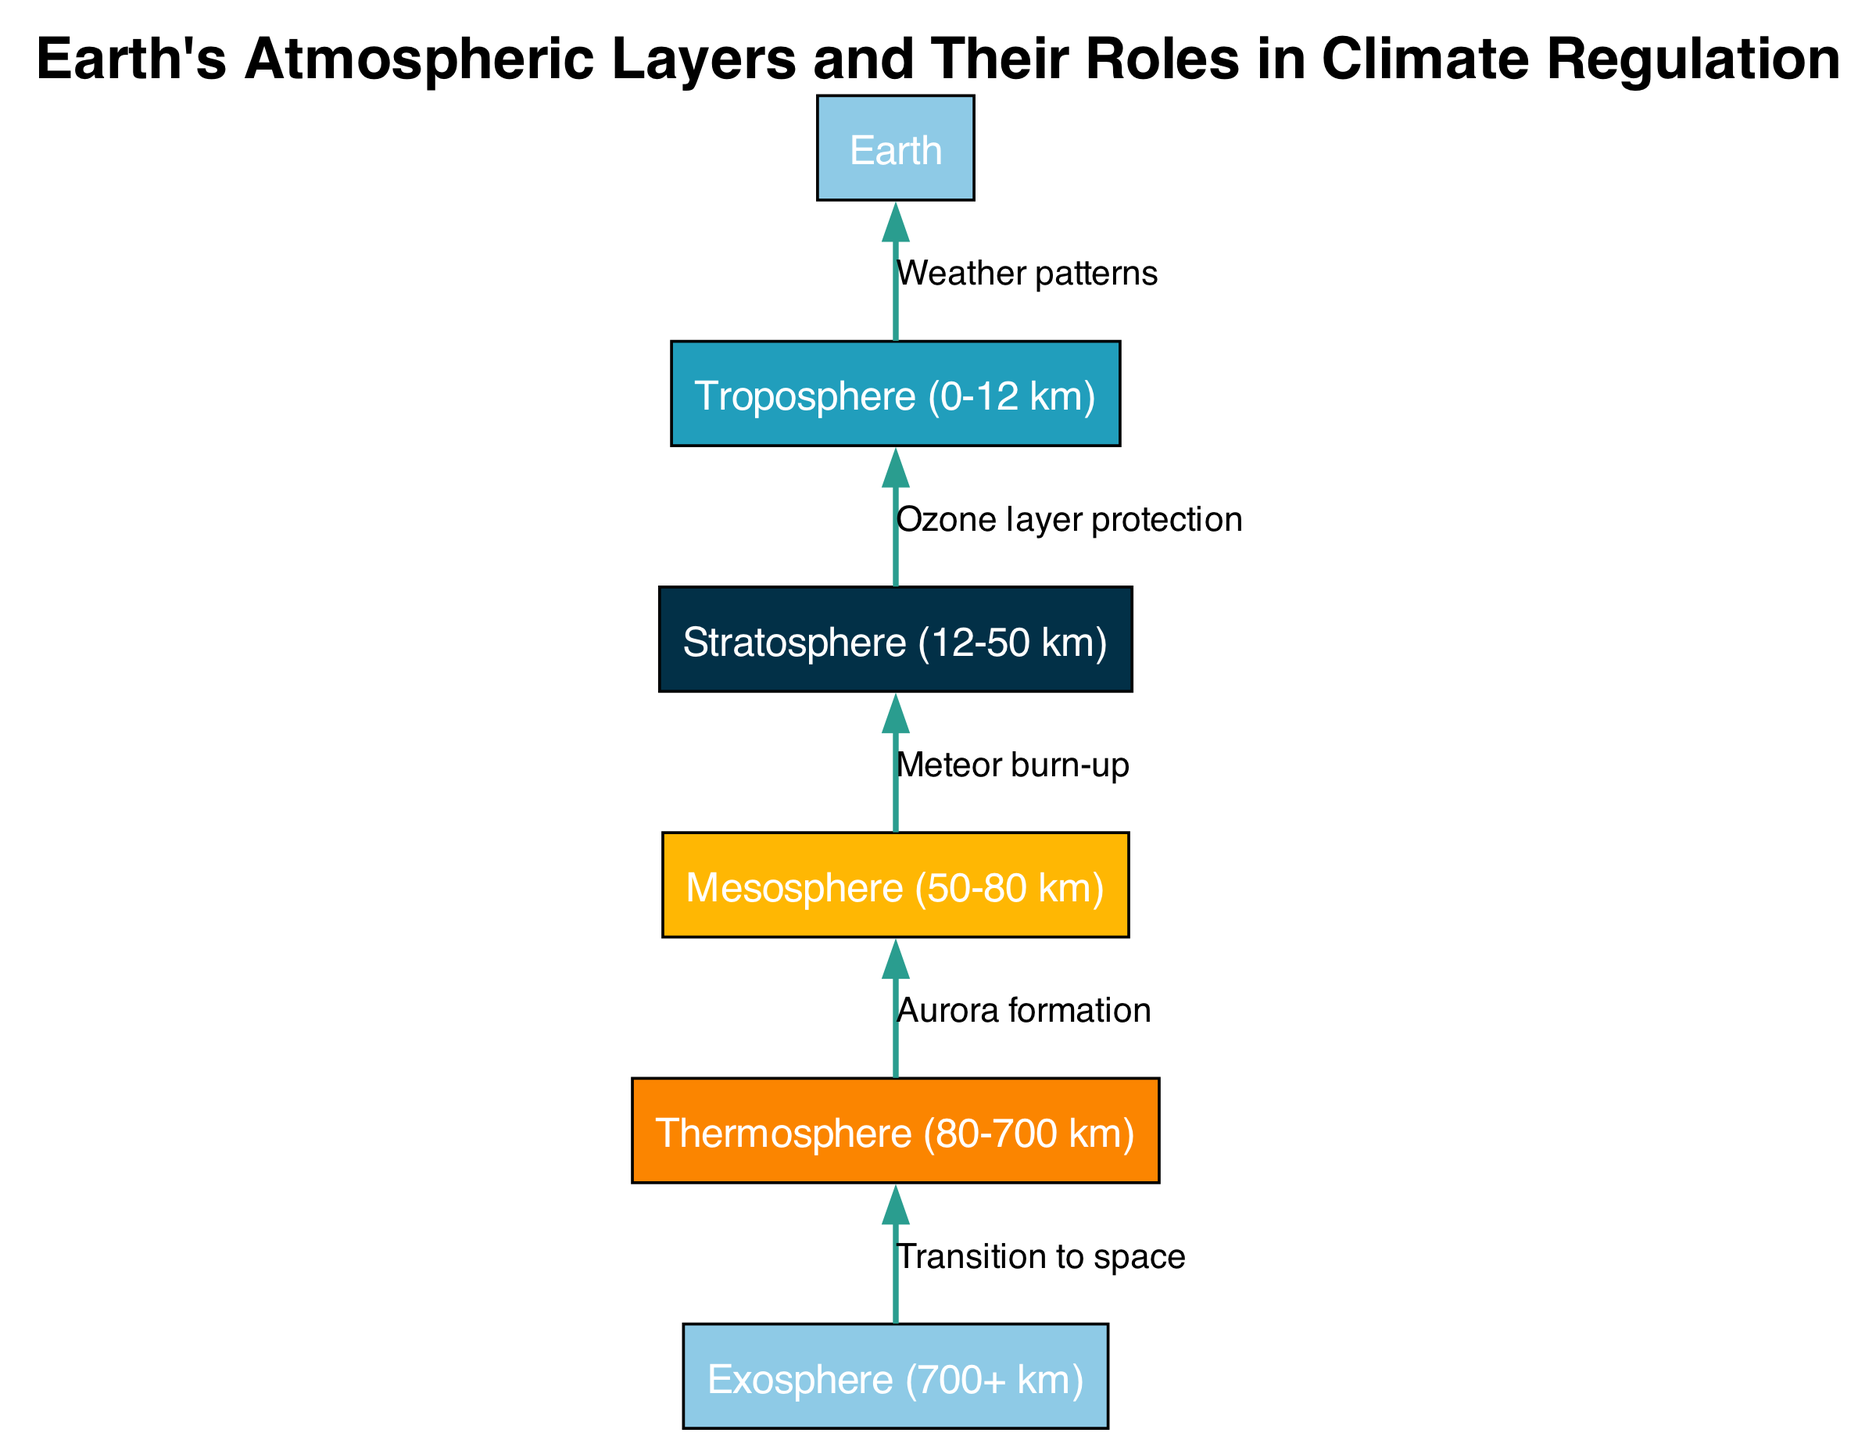What is the highest atmospheric layer shown in the diagram? The highest layer illustrated in the diagram is identified as the Exosphere, which extends beyond 700 kilometers above Earth.
Answer: Exosphere (700+ km) How many layers of the atmosphere are represented? The diagram includes five distinct atmospheric layers: Troposphere, Stratosphere, Mesosphere, Thermosphere, and Exosphere, totaling five layers.
Answer: 5 What is the role of the Stratosphere? The Stratosphere is primarily associated with Ozone layer protection, which plays a crucial role in filtering harmful UV radiation from the sun and thereby protects life on Earth.
Answer: Ozone layer protection Which layer is responsible for weather patterns? The Troposphere is directly linked with weather patterns, as it is where most weather events, such as clouds and storms, occur.
Answer: Troposphere (0-12 km) Which layer does the Thermosphere directly influence? The Thermosphere influences the Mesosphere as it transitions to the higher atmospheric region, playing a role in phenomena such as aurora formation.
Answer: Mesosphere What connects the Mesosphere and the Stratosphere? The connection between the Mesosphere and the Stratosphere is characterized by meteor burn-up occurring in the Mesosphere, which is visually represented by an edge labeled 'Meteor burn-up'.
Answer: Meteor burn-up From which layer does the transition to space begin? The transition to space begins from the Exosphere, as indicated by its positioning and the corresponding label in the diagram that signifies movement beyond Earth's atmosphere.
Answer: Exosphere (700+ km) What visual element indicates relationship direction? The edges between nodes are used as visual elements to indicate relationship direction in the diagram, showing the flow of influence and function from one layer to another.
Answer: Edges Which element in the diagram notably contributes to aurora formation? The Thermosphere notably contributes to aurora formation, indicated by the specific labeling of the edge leading to the Mesosphere.
Answer: Thermosphere 